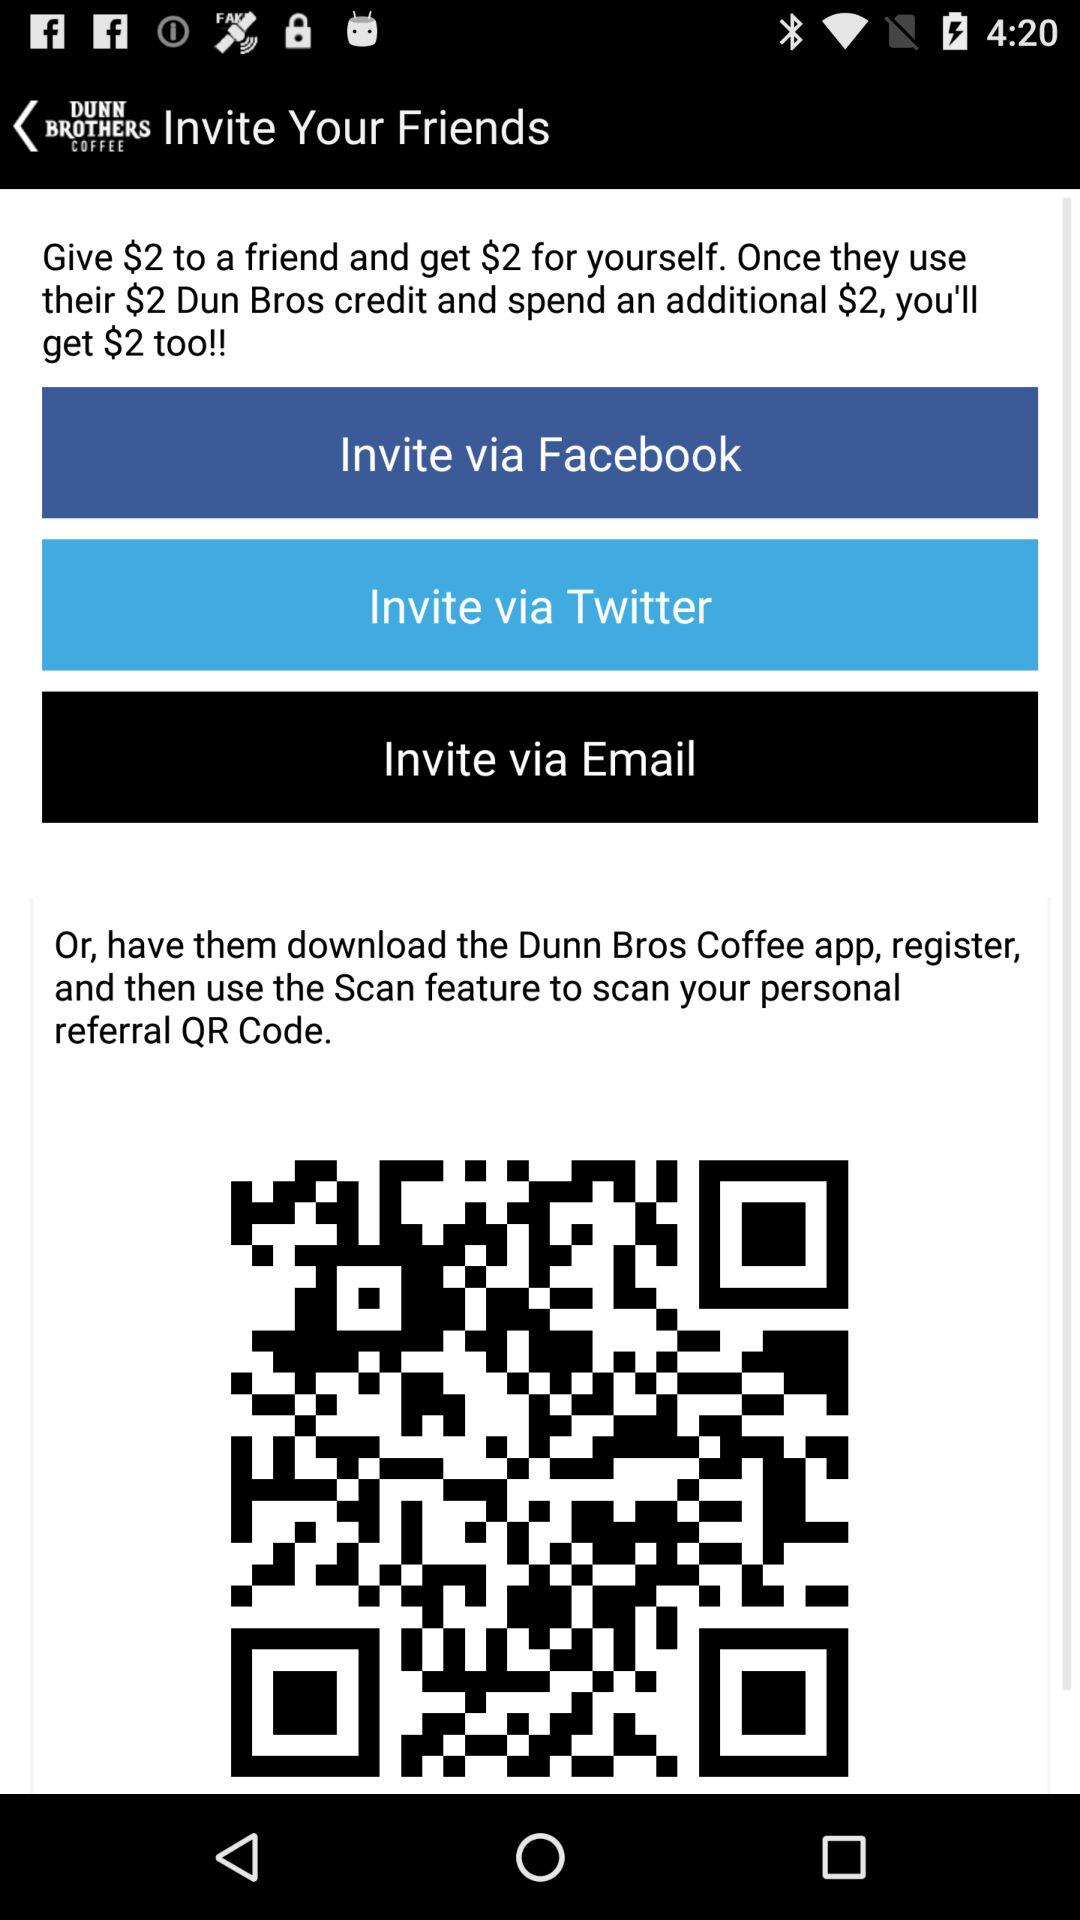How many ways can I invite a friend?
Answer the question using a single word or phrase. 3 